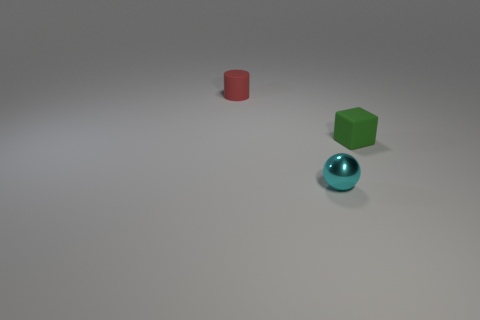Add 3 small metal balls. How many objects exist? 6 Subtract all blocks. How many objects are left? 2 Add 1 large green matte cylinders. How many large green matte cylinders exist? 1 Subtract 0 brown spheres. How many objects are left? 3 Subtract all small cyan things. Subtract all tiny yellow cubes. How many objects are left? 2 Add 3 metallic spheres. How many metallic spheres are left? 4 